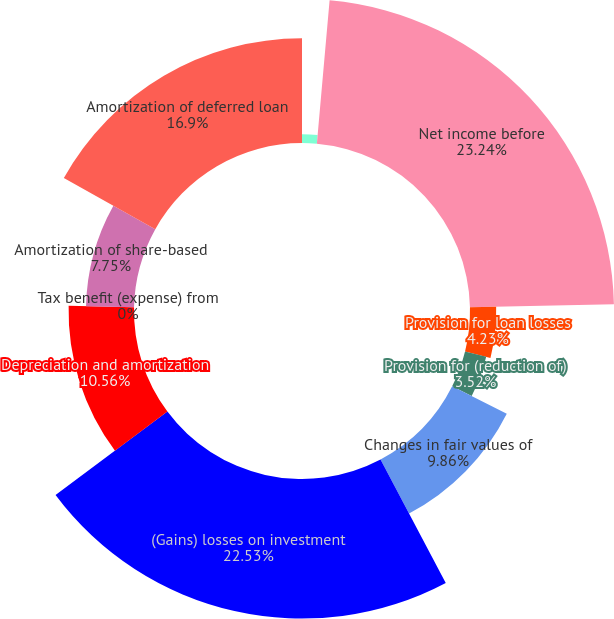<chart> <loc_0><loc_0><loc_500><loc_500><pie_chart><fcel>(Dollars in thousands)<fcel>Net income before<fcel>Provision for loan losses<fcel>Provision for (reduction of)<fcel>Changes in fair values of<fcel>(Gains) losses on investment<fcel>Depreciation and amortization<fcel>Tax benefit (expense) from<fcel>Amortization of share-based<fcel>Amortization of deferred loan<nl><fcel>1.41%<fcel>23.24%<fcel>4.23%<fcel>3.52%<fcel>9.86%<fcel>22.53%<fcel>10.56%<fcel>0.0%<fcel>7.75%<fcel>16.9%<nl></chart> 